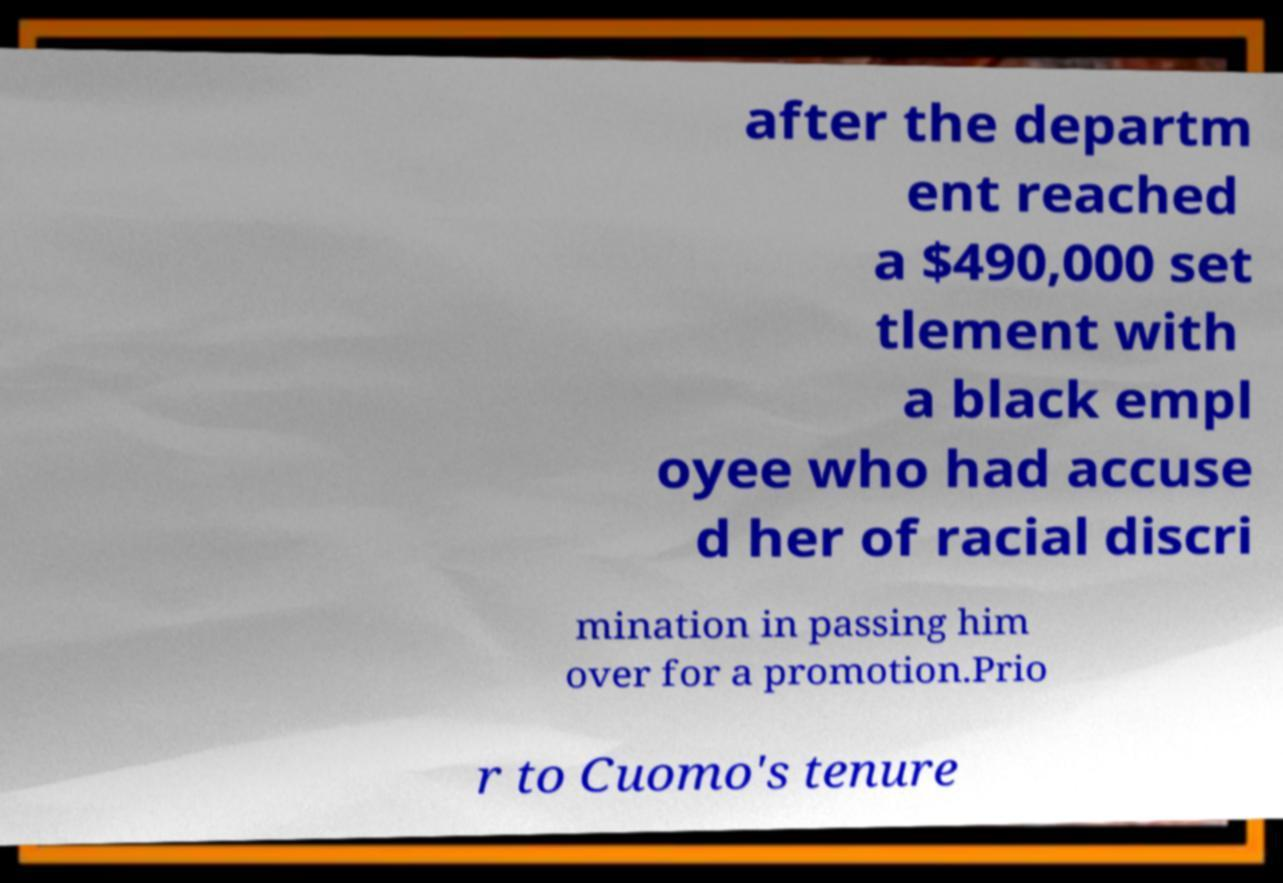Please identify and transcribe the text found in this image. after the departm ent reached a $490,000 set tlement with a black empl oyee who had accuse d her of racial discri mination in passing him over for a promotion.Prio r to Cuomo's tenure 